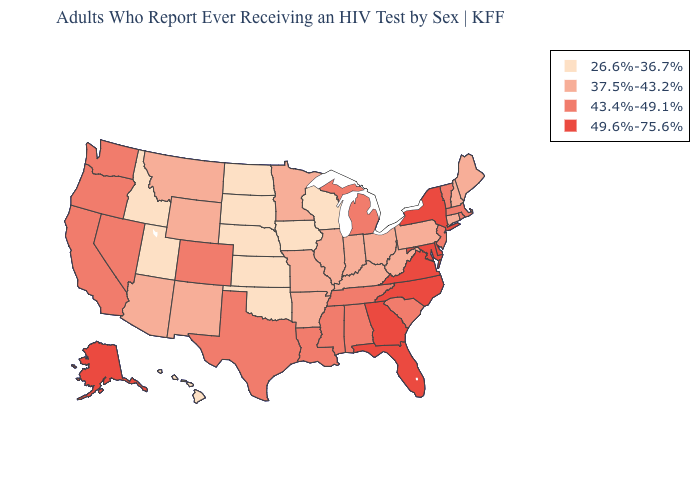What is the highest value in the USA?
Concise answer only. 49.6%-75.6%. Which states hav the highest value in the MidWest?
Quick response, please. Michigan. What is the highest value in the USA?
Short answer required. 49.6%-75.6%. What is the highest value in the USA?
Short answer required. 49.6%-75.6%. Does Alaska have the highest value in the West?
Give a very brief answer. Yes. Name the states that have a value in the range 26.6%-36.7%?
Be succinct. Hawaii, Idaho, Iowa, Kansas, Nebraska, North Dakota, Oklahoma, South Dakota, Utah, Wisconsin. What is the value of Kentucky?
Write a very short answer. 37.5%-43.2%. What is the highest value in the USA?
Write a very short answer. 49.6%-75.6%. Among the states that border Oklahoma , which have the lowest value?
Write a very short answer. Kansas. How many symbols are there in the legend?
Concise answer only. 4. How many symbols are there in the legend?
Be succinct. 4. What is the value of Kentucky?
Answer briefly. 37.5%-43.2%. Name the states that have a value in the range 26.6%-36.7%?
Be succinct. Hawaii, Idaho, Iowa, Kansas, Nebraska, North Dakota, Oklahoma, South Dakota, Utah, Wisconsin. Name the states that have a value in the range 26.6%-36.7%?
Give a very brief answer. Hawaii, Idaho, Iowa, Kansas, Nebraska, North Dakota, Oklahoma, South Dakota, Utah, Wisconsin. What is the highest value in the Northeast ?
Keep it brief. 49.6%-75.6%. 